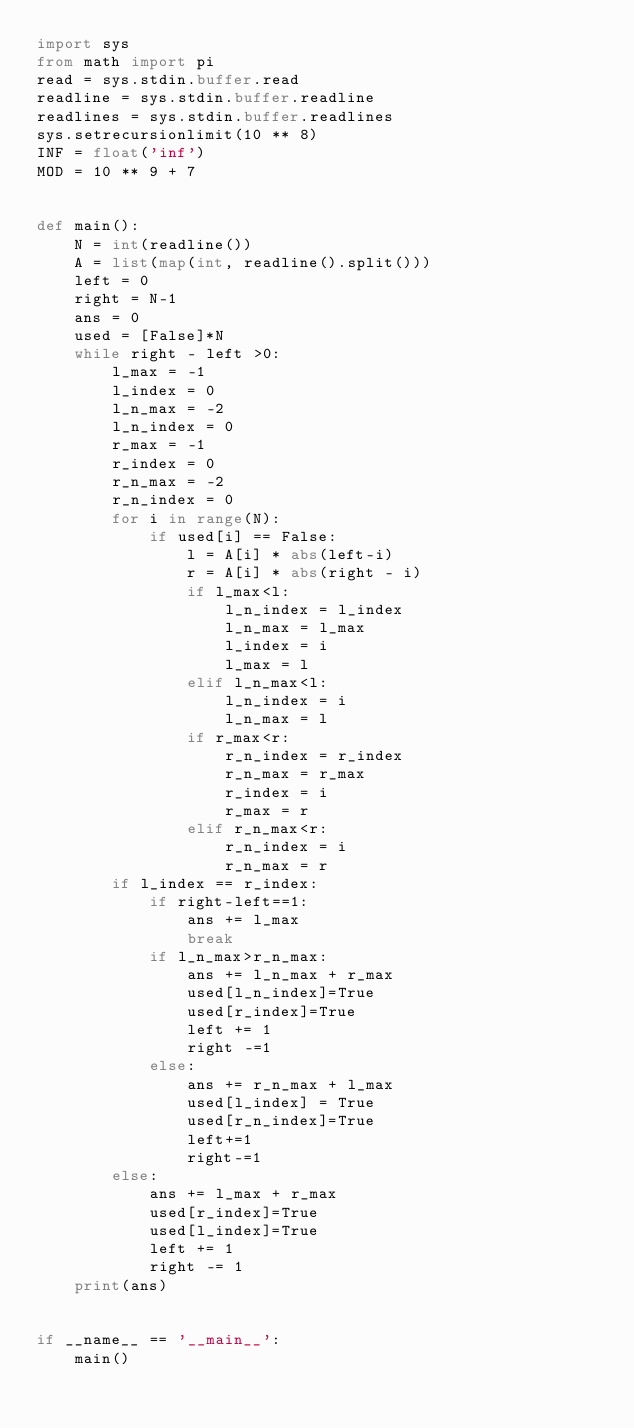Convert code to text. <code><loc_0><loc_0><loc_500><loc_500><_Python_>import sys
from math import pi
read = sys.stdin.buffer.read
readline = sys.stdin.buffer.readline
readlines = sys.stdin.buffer.readlines
sys.setrecursionlimit(10 ** 8)
INF = float('inf')
MOD = 10 ** 9 + 7


def main():
    N = int(readline())
    A = list(map(int, readline().split()))
    left = 0
    right = N-1
    ans = 0
    used = [False]*N
    while right - left >0:
        l_max = -1
        l_index = 0
        l_n_max = -2
        l_n_index = 0
        r_max = -1
        r_index = 0
        r_n_max = -2
        r_n_index = 0
        for i in range(N):
            if used[i] == False:
                l = A[i] * abs(left-i)
                r = A[i] * abs(right - i)
                if l_max<l:
                    l_n_index = l_index
                    l_n_max = l_max
                    l_index = i
                    l_max = l
                elif l_n_max<l:
                    l_n_index = i
                    l_n_max = l
                if r_max<r:
                    r_n_index = r_index
                    r_n_max = r_max
                    r_index = i
                    r_max = r
                elif r_n_max<r:
                    r_n_index = i
                    r_n_max = r
        if l_index == r_index:
            if right-left==1:
                ans += l_max
                break
            if l_n_max>r_n_max:
                ans += l_n_max + r_max
                used[l_n_index]=True
                used[r_index]=True
                left += 1
                right -=1
            else:
                ans += r_n_max + l_max
                used[l_index] = True
                used[r_n_index]=True
                left+=1
                right-=1
        else:
            ans += l_max + r_max
            used[r_index]=True
            used[l_index]=True
            left += 1
            right -= 1
    print(ans)


if __name__ == '__main__':
    main()</code> 